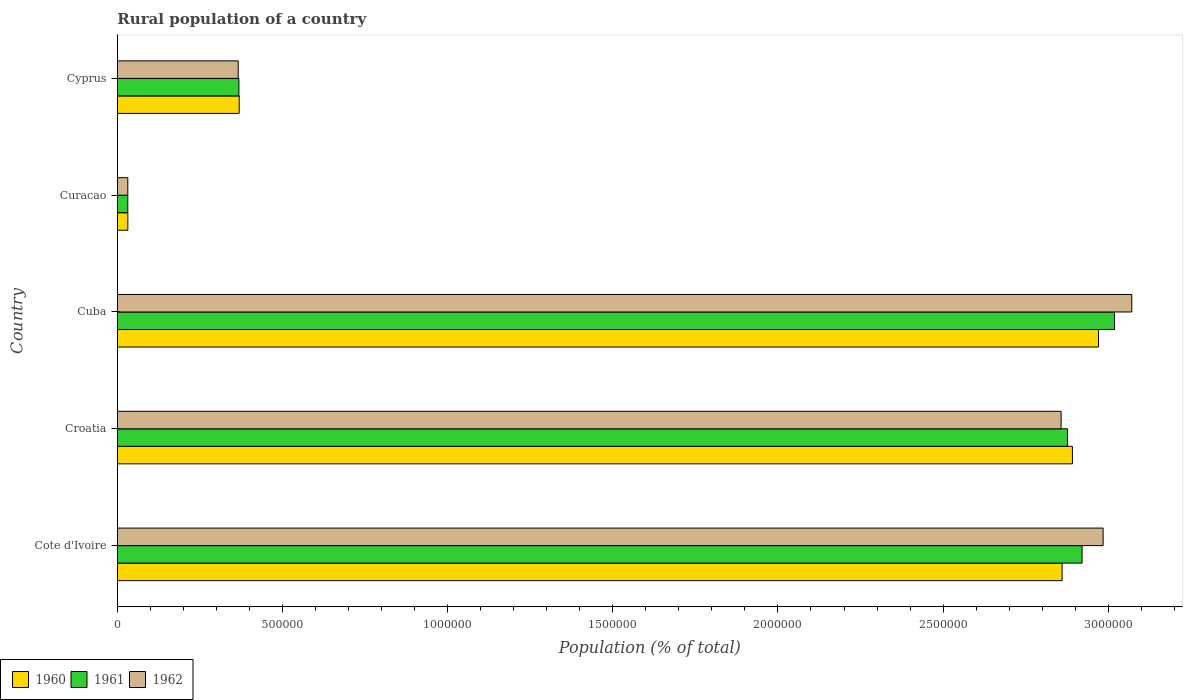How many groups of bars are there?
Keep it short and to the point. 5. Are the number of bars per tick equal to the number of legend labels?
Offer a terse response. Yes. What is the label of the 4th group of bars from the top?
Make the answer very short. Croatia. What is the rural population in 1960 in Cyprus?
Offer a terse response. 3.69e+05. Across all countries, what is the maximum rural population in 1962?
Make the answer very short. 3.07e+06. Across all countries, what is the minimum rural population in 1961?
Your response must be concise. 3.14e+04. In which country was the rural population in 1961 maximum?
Provide a short and direct response. Cuba. In which country was the rural population in 1961 minimum?
Keep it short and to the point. Curacao. What is the total rural population in 1960 in the graph?
Offer a very short reply. 9.12e+06. What is the difference between the rural population in 1961 in Cuba and that in Cyprus?
Your answer should be compact. 2.65e+06. What is the difference between the rural population in 1962 in Curacao and the rural population in 1961 in Cote d'Ivoire?
Your answer should be very brief. -2.89e+06. What is the average rural population in 1961 per country?
Provide a succinct answer. 1.84e+06. What is the difference between the rural population in 1960 and rural population in 1961 in Croatia?
Ensure brevity in your answer.  1.48e+04. What is the ratio of the rural population in 1960 in Cote d'Ivoire to that in Cuba?
Give a very brief answer. 0.96. Is the rural population in 1962 in Cote d'Ivoire less than that in Croatia?
Your answer should be compact. No. What is the difference between the highest and the second highest rural population in 1960?
Your response must be concise. 7.90e+04. What is the difference between the highest and the lowest rural population in 1960?
Your answer should be compact. 2.94e+06. What does the 1st bar from the top in Croatia represents?
Your response must be concise. 1962. What does the 2nd bar from the bottom in Curacao represents?
Provide a short and direct response. 1961. Are all the bars in the graph horizontal?
Give a very brief answer. Yes. How many countries are there in the graph?
Make the answer very short. 5. Does the graph contain any zero values?
Your answer should be very brief. No. Where does the legend appear in the graph?
Provide a succinct answer. Bottom left. What is the title of the graph?
Ensure brevity in your answer.  Rural population of a country. Does "1983" appear as one of the legend labels in the graph?
Your response must be concise. No. What is the label or title of the X-axis?
Give a very brief answer. Population (% of total). What is the label or title of the Y-axis?
Keep it short and to the point. Country. What is the Population (% of total) of 1960 in Cote d'Ivoire?
Keep it short and to the point. 2.86e+06. What is the Population (% of total) of 1961 in Cote d'Ivoire?
Provide a short and direct response. 2.92e+06. What is the Population (% of total) of 1962 in Cote d'Ivoire?
Ensure brevity in your answer.  2.98e+06. What is the Population (% of total) in 1960 in Croatia?
Give a very brief answer. 2.89e+06. What is the Population (% of total) in 1961 in Croatia?
Give a very brief answer. 2.88e+06. What is the Population (% of total) of 1962 in Croatia?
Keep it short and to the point. 2.86e+06. What is the Population (% of total) in 1960 in Cuba?
Your answer should be very brief. 2.97e+06. What is the Population (% of total) in 1961 in Cuba?
Provide a succinct answer. 3.02e+06. What is the Population (% of total) in 1962 in Cuba?
Offer a terse response. 3.07e+06. What is the Population (% of total) in 1960 in Curacao?
Provide a short and direct response. 3.16e+04. What is the Population (% of total) in 1961 in Curacao?
Keep it short and to the point. 3.14e+04. What is the Population (% of total) in 1962 in Curacao?
Keep it short and to the point. 3.15e+04. What is the Population (% of total) of 1960 in Cyprus?
Provide a succinct answer. 3.69e+05. What is the Population (% of total) of 1961 in Cyprus?
Give a very brief answer. 3.68e+05. What is the Population (% of total) of 1962 in Cyprus?
Your answer should be very brief. 3.66e+05. Across all countries, what is the maximum Population (% of total) in 1960?
Offer a very short reply. 2.97e+06. Across all countries, what is the maximum Population (% of total) of 1961?
Make the answer very short. 3.02e+06. Across all countries, what is the maximum Population (% of total) of 1962?
Give a very brief answer. 3.07e+06. Across all countries, what is the minimum Population (% of total) in 1960?
Your response must be concise. 3.16e+04. Across all countries, what is the minimum Population (% of total) of 1961?
Offer a terse response. 3.14e+04. Across all countries, what is the minimum Population (% of total) of 1962?
Give a very brief answer. 3.15e+04. What is the total Population (% of total) of 1960 in the graph?
Give a very brief answer. 9.12e+06. What is the total Population (% of total) in 1961 in the graph?
Provide a short and direct response. 9.22e+06. What is the total Population (% of total) of 1962 in the graph?
Keep it short and to the point. 9.31e+06. What is the difference between the Population (% of total) of 1960 in Cote d'Ivoire and that in Croatia?
Make the answer very short. -3.12e+04. What is the difference between the Population (% of total) of 1961 in Cote d'Ivoire and that in Croatia?
Keep it short and to the point. 4.41e+04. What is the difference between the Population (% of total) of 1962 in Cote d'Ivoire and that in Croatia?
Your response must be concise. 1.27e+05. What is the difference between the Population (% of total) of 1960 in Cote d'Ivoire and that in Cuba?
Your answer should be very brief. -1.10e+05. What is the difference between the Population (% of total) of 1961 in Cote d'Ivoire and that in Cuba?
Make the answer very short. -9.80e+04. What is the difference between the Population (% of total) in 1962 in Cote d'Ivoire and that in Cuba?
Provide a succinct answer. -8.68e+04. What is the difference between the Population (% of total) of 1960 in Cote d'Ivoire and that in Curacao?
Provide a short and direct response. 2.83e+06. What is the difference between the Population (% of total) in 1961 in Cote d'Ivoire and that in Curacao?
Provide a short and direct response. 2.89e+06. What is the difference between the Population (% of total) of 1962 in Cote d'Ivoire and that in Curacao?
Provide a short and direct response. 2.95e+06. What is the difference between the Population (% of total) of 1960 in Cote d'Ivoire and that in Cyprus?
Make the answer very short. 2.49e+06. What is the difference between the Population (% of total) in 1961 in Cote d'Ivoire and that in Cyprus?
Your answer should be compact. 2.55e+06. What is the difference between the Population (% of total) in 1962 in Cote d'Ivoire and that in Cyprus?
Your answer should be very brief. 2.62e+06. What is the difference between the Population (% of total) of 1960 in Croatia and that in Cuba?
Your answer should be compact. -7.90e+04. What is the difference between the Population (% of total) of 1961 in Croatia and that in Cuba?
Give a very brief answer. -1.42e+05. What is the difference between the Population (% of total) of 1962 in Croatia and that in Cuba?
Offer a terse response. -2.14e+05. What is the difference between the Population (% of total) in 1960 in Croatia and that in Curacao?
Your answer should be very brief. 2.86e+06. What is the difference between the Population (% of total) of 1961 in Croatia and that in Curacao?
Your answer should be compact. 2.85e+06. What is the difference between the Population (% of total) of 1962 in Croatia and that in Curacao?
Provide a short and direct response. 2.83e+06. What is the difference between the Population (% of total) in 1960 in Croatia and that in Cyprus?
Your answer should be very brief. 2.52e+06. What is the difference between the Population (% of total) in 1961 in Croatia and that in Cyprus?
Make the answer very short. 2.51e+06. What is the difference between the Population (% of total) in 1962 in Croatia and that in Cyprus?
Make the answer very short. 2.49e+06. What is the difference between the Population (% of total) of 1960 in Cuba and that in Curacao?
Give a very brief answer. 2.94e+06. What is the difference between the Population (% of total) in 1961 in Cuba and that in Curacao?
Offer a very short reply. 2.99e+06. What is the difference between the Population (% of total) of 1962 in Cuba and that in Curacao?
Your answer should be very brief. 3.04e+06. What is the difference between the Population (% of total) in 1960 in Cuba and that in Cyprus?
Your answer should be very brief. 2.60e+06. What is the difference between the Population (% of total) in 1961 in Cuba and that in Cyprus?
Provide a short and direct response. 2.65e+06. What is the difference between the Population (% of total) in 1962 in Cuba and that in Cyprus?
Provide a short and direct response. 2.71e+06. What is the difference between the Population (% of total) in 1960 in Curacao and that in Cyprus?
Ensure brevity in your answer.  -3.37e+05. What is the difference between the Population (% of total) of 1961 in Curacao and that in Cyprus?
Give a very brief answer. -3.36e+05. What is the difference between the Population (% of total) in 1962 in Curacao and that in Cyprus?
Your answer should be compact. -3.34e+05. What is the difference between the Population (% of total) of 1960 in Cote d'Ivoire and the Population (% of total) of 1961 in Croatia?
Offer a very short reply. -1.64e+04. What is the difference between the Population (% of total) in 1960 in Cote d'Ivoire and the Population (% of total) in 1962 in Croatia?
Your answer should be very brief. 3039. What is the difference between the Population (% of total) of 1961 in Cote d'Ivoire and the Population (% of total) of 1962 in Croatia?
Make the answer very short. 6.35e+04. What is the difference between the Population (% of total) of 1960 in Cote d'Ivoire and the Population (% of total) of 1961 in Cuba?
Provide a short and direct response. -1.58e+05. What is the difference between the Population (% of total) in 1960 in Cote d'Ivoire and the Population (% of total) in 1962 in Cuba?
Provide a short and direct response. -2.11e+05. What is the difference between the Population (% of total) in 1961 in Cote d'Ivoire and the Population (% of total) in 1962 in Cuba?
Provide a short and direct response. -1.50e+05. What is the difference between the Population (% of total) in 1960 in Cote d'Ivoire and the Population (% of total) in 1961 in Curacao?
Keep it short and to the point. 2.83e+06. What is the difference between the Population (% of total) of 1960 in Cote d'Ivoire and the Population (% of total) of 1962 in Curacao?
Give a very brief answer. 2.83e+06. What is the difference between the Population (% of total) in 1961 in Cote d'Ivoire and the Population (% of total) in 1962 in Curacao?
Offer a very short reply. 2.89e+06. What is the difference between the Population (% of total) in 1960 in Cote d'Ivoire and the Population (% of total) in 1961 in Cyprus?
Your response must be concise. 2.49e+06. What is the difference between the Population (% of total) in 1960 in Cote d'Ivoire and the Population (% of total) in 1962 in Cyprus?
Make the answer very short. 2.49e+06. What is the difference between the Population (% of total) in 1961 in Cote d'Ivoire and the Population (% of total) in 1962 in Cyprus?
Your response must be concise. 2.56e+06. What is the difference between the Population (% of total) of 1960 in Croatia and the Population (% of total) of 1961 in Cuba?
Your answer should be compact. -1.27e+05. What is the difference between the Population (% of total) of 1960 in Croatia and the Population (% of total) of 1962 in Cuba?
Your response must be concise. -1.80e+05. What is the difference between the Population (% of total) of 1961 in Croatia and the Population (% of total) of 1962 in Cuba?
Provide a short and direct response. -1.95e+05. What is the difference between the Population (% of total) of 1960 in Croatia and the Population (% of total) of 1961 in Curacao?
Offer a very short reply. 2.86e+06. What is the difference between the Population (% of total) in 1960 in Croatia and the Population (% of total) in 1962 in Curacao?
Provide a short and direct response. 2.86e+06. What is the difference between the Population (% of total) of 1961 in Croatia and the Population (% of total) of 1962 in Curacao?
Your answer should be very brief. 2.85e+06. What is the difference between the Population (% of total) in 1960 in Croatia and the Population (% of total) in 1961 in Cyprus?
Give a very brief answer. 2.52e+06. What is the difference between the Population (% of total) of 1960 in Croatia and the Population (% of total) of 1962 in Cyprus?
Give a very brief answer. 2.53e+06. What is the difference between the Population (% of total) in 1961 in Croatia and the Population (% of total) in 1962 in Cyprus?
Your answer should be very brief. 2.51e+06. What is the difference between the Population (% of total) of 1960 in Cuba and the Population (% of total) of 1961 in Curacao?
Give a very brief answer. 2.94e+06. What is the difference between the Population (% of total) of 1960 in Cuba and the Population (% of total) of 1962 in Curacao?
Ensure brevity in your answer.  2.94e+06. What is the difference between the Population (% of total) of 1961 in Cuba and the Population (% of total) of 1962 in Curacao?
Provide a short and direct response. 2.99e+06. What is the difference between the Population (% of total) of 1960 in Cuba and the Population (% of total) of 1961 in Cyprus?
Offer a terse response. 2.60e+06. What is the difference between the Population (% of total) of 1960 in Cuba and the Population (% of total) of 1962 in Cyprus?
Keep it short and to the point. 2.60e+06. What is the difference between the Population (% of total) of 1961 in Cuba and the Population (% of total) of 1962 in Cyprus?
Give a very brief answer. 2.65e+06. What is the difference between the Population (% of total) in 1960 in Curacao and the Population (% of total) in 1961 in Cyprus?
Provide a short and direct response. -3.36e+05. What is the difference between the Population (% of total) in 1960 in Curacao and the Population (% of total) in 1962 in Cyprus?
Make the answer very short. -3.34e+05. What is the difference between the Population (% of total) in 1961 in Curacao and the Population (% of total) in 1962 in Cyprus?
Offer a very short reply. -3.34e+05. What is the average Population (% of total) in 1960 per country?
Keep it short and to the point. 1.82e+06. What is the average Population (% of total) of 1961 per country?
Your response must be concise. 1.84e+06. What is the average Population (% of total) of 1962 per country?
Ensure brevity in your answer.  1.86e+06. What is the difference between the Population (% of total) of 1960 and Population (% of total) of 1961 in Cote d'Ivoire?
Your answer should be compact. -6.05e+04. What is the difference between the Population (% of total) of 1960 and Population (% of total) of 1962 in Cote d'Ivoire?
Keep it short and to the point. -1.24e+05. What is the difference between the Population (% of total) in 1961 and Population (% of total) in 1962 in Cote d'Ivoire?
Give a very brief answer. -6.37e+04. What is the difference between the Population (% of total) of 1960 and Population (% of total) of 1961 in Croatia?
Provide a short and direct response. 1.48e+04. What is the difference between the Population (% of total) in 1960 and Population (% of total) in 1962 in Croatia?
Ensure brevity in your answer.  3.42e+04. What is the difference between the Population (% of total) of 1961 and Population (% of total) of 1962 in Croatia?
Your response must be concise. 1.94e+04. What is the difference between the Population (% of total) in 1960 and Population (% of total) in 1961 in Cuba?
Make the answer very short. -4.82e+04. What is the difference between the Population (% of total) in 1960 and Population (% of total) in 1962 in Cuba?
Ensure brevity in your answer.  -1.01e+05. What is the difference between the Population (% of total) of 1961 and Population (% of total) of 1962 in Cuba?
Your answer should be very brief. -5.25e+04. What is the difference between the Population (% of total) in 1960 and Population (% of total) in 1961 in Curacao?
Provide a succinct answer. 165. What is the difference between the Population (% of total) of 1960 and Population (% of total) of 1962 in Curacao?
Ensure brevity in your answer.  94. What is the difference between the Population (% of total) in 1961 and Population (% of total) in 1962 in Curacao?
Make the answer very short. -71. What is the difference between the Population (% of total) in 1960 and Population (% of total) in 1961 in Cyprus?
Your answer should be very brief. 922. What is the difference between the Population (% of total) in 1960 and Population (% of total) in 1962 in Cyprus?
Your answer should be very brief. 2977. What is the difference between the Population (% of total) of 1961 and Population (% of total) of 1962 in Cyprus?
Provide a short and direct response. 2055. What is the ratio of the Population (% of total) of 1960 in Cote d'Ivoire to that in Croatia?
Provide a succinct answer. 0.99. What is the ratio of the Population (% of total) in 1961 in Cote d'Ivoire to that in Croatia?
Give a very brief answer. 1.02. What is the ratio of the Population (% of total) in 1962 in Cote d'Ivoire to that in Croatia?
Keep it short and to the point. 1.04. What is the ratio of the Population (% of total) of 1960 in Cote d'Ivoire to that in Cuba?
Offer a terse response. 0.96. What is the ratio of the Population (% of total) of 1961 in Cote d'Ivoire to that in Cuba?
Keep it short and to the point. 0.97. What is the ratio of the Population (% of total) in 1962 in Cote d'Ivoire to that in Cuba?
Make the answer very short. 0.97. What is the ratio of the Population (% of total) in 1960 in Cote d'Ivoire to that in Curacao?
Offer a very short reply. 90.61. What is the ratio of the Population (% of total) in 1961 in Cote d'Ivoire to that in Curacao?
Make the answer very short. 93.01. What is the ratio of the Population (% of total) of 1962 in Cote d'Ivoire to that in Curacao?
Provide a succinct answer. 94.83. What is the ratio of the Population (% of total) of 1960 in Cote d'Ivoire to that in Cyprus?
Provide a short and direct response. 7.76. What is the ratio of the Population (% of total) in 1961 in Cote d'Ivoire to that in Cyprus?
Keep it short and to the point. 7.94. What is the ratio of the Population (% of total) in 1962 in Cote d'Ivoire to that in Cyprus?
Keep it short and to the point. 8.16. What is the ratio of the Population (% of total) of 1960 in Croatia to that in Cuba?
Offer a terse response. 0.97. What is the ratio of the Population (% of total) in 1961 in Croatia to that in Cuba?
Ensure brevity in your answer.  0.95. What is the ratio of the Population (% of total) in 1962 in Croatia to that in Cuba?
Keep it short and to the point. 0.93. What is the ratio of the Population (% of total) in 1960 in Croatia to that in Curacao?
Make the answer very short. 91.6. What is the ratio of the Population (% of total) in 1961 in Croatia to that in Curacao?
Your answer should be very brief. 91.61. What is the ratio of the Population (% of total) of 1962 in Croatia to that in Curacao?
Provide a short and direct response. 90.79. What is the ratio of the Population (% of total) in 1960 in Croatia to that in Cyprus?
Make the answer very short. 7.84. What is the ratio of the Population (% of total) of 1961 in Croatia to that in Cyprus?
Provide a succinct answer. 7.82. What is the ratio of the Population (% of total) in 1962 in Croatia to that in Cyprus?
Make the answer very short. 7.81. What is the ratio of the Population (% of total) of 1960 in Cuba to that in Curacao?
Provide a succinct answer. 94.1. What is the ratio of the Population (% of total) of 1961 in Cuba to that in Curacao?
Offer a terse response. 96.13. What is the ratio of the Population (% of total) in 1962 in Cuba to that in Curacao?
Provide a succinct answer. 97.58. What is the ratio of the Population (% of total) in 1960 in Cuba to that in Cyprus?
Your answer should be compact. 8.05. What is the ratio of the Population (% of total) of 1961 in Cuba to that in Cyprus?
Your answer should be compact. 8.21. What is the ratio of the Population (% of total) of 1962 in Cuba to that in Cyprus?
Your answer should be compact. 8.4. What is the ratio of the Population (% of total) of 1960 in Curacao to that in Cyprus?
Offer a very short reply. 0.09. What is the ratio of the Population (% of total) of 1961 in Curacao to that in Cyprus?
Make the answer very short. 0.09. What is the ratio of the Population (% of total) in 1962 in Curacao to that in Cyprus?
Keep it short and to the point. 0.09. What is the difference between the highest and the second highest Population (% of total) in 1960?
Your answer should be very brief. 7.90e+04. What is the difference between the highest and the second highest Population (% of total) of 1961?
Provide a short and direct response. 9.80e+04. What is the difference between the highest and the second highest Population (% of total) of 1962?
Provide a short and direct response. 8.68e+04. What is the difference between the highest and the lowest Population (% of total) in 1960?
Offer a very short reply. 2.94e+06. What is the difference between the highest and the lowest Population (% of total) in 1961?
Ensure brevity in your answer.  2.99e+06. What is the difference between the highest and the lowest Population (% of total) in 1962?
Offer a terse response. 3.04e+06. 